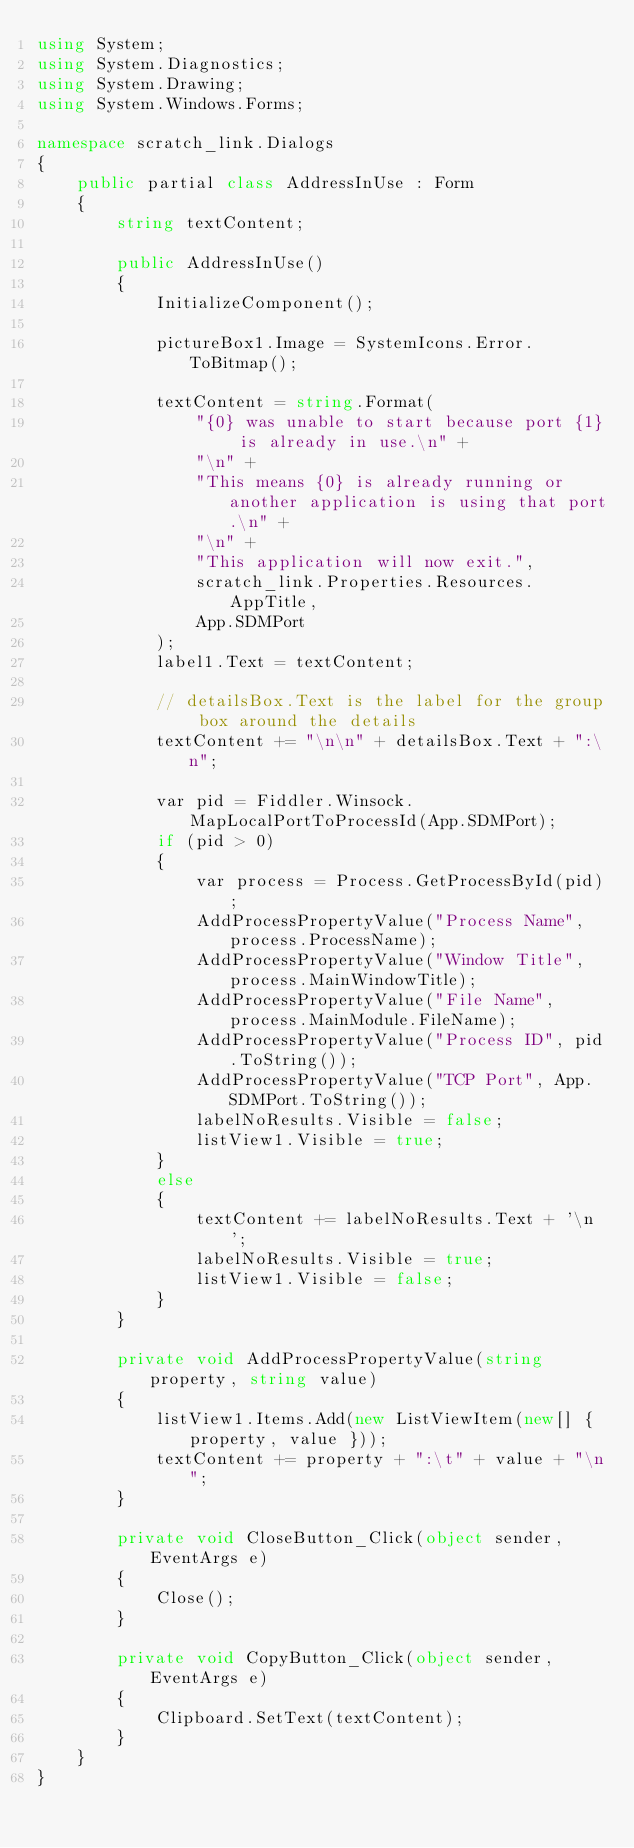Convert code to text. <code><loc_0><loc_0><loc_500><loc_500><_C#_>using System;
using System.Diagnostics;
using System.Drawing;
using System.Windows.Forms;

namespace scratch_link.Dialogs
{
    public partial class AddressInUse : Form
    {
        string textContent;

        public AddressInUse()
        {
            InitializeComponent();

            pictureBox1.Image = SystemIcons.Error.ToBitmap();

            textContent = string.Format(
                "{0} was unable to start because port {1} is already in use.\n" +
                "\n" +
                "This means {0} is already running or another application is using that port.\n" +
                "\n" +
                "This application will now exit.",
                scratch_link.Properties.Resources.AppTitle,
                App.SDMPort
            );
            label1.Text = textContent;

            // detailsBox.Text is the label for the group box around the details
            textContent += "\n\n" + detailsBox.Text + ":\n";

            var pid = Fiddler.Winsock.MapLocalPortToProcessId(App.SDMPort);
            if (pid > 0)
            {
                var process = Process.GetProcessById(pid);
                AddProcessPropertyValue("Process Name", process.ProcessName);
                AddProcessPropertyValue("Window Title", process.MainWindowTitle);
                AddProcessPropertyValue("File Name", process.MainModule.FileName);
                AddProcessPropertyValue("Process ID", pid.ToString());
                AddProcessPropertyValue("TCP Port", App.SDMPort.ToString());
                labelNoResults.Visible = false;
                listView1.Visible = true;
            }
            else
            {
                textContent += labelNoResults.Text + '\n';
                labelNoResults.Visible = true;
                listView1.Visible = false;
            }
        }

        private void AddProcessPropertyValue(string property, string value)
        {
            listView1.Items.Add(new ListViewItem(new[] { property, value }));
            textContent += property + ":\t" + value + "\n";
        }

        private void CloseButton_Click(object sender, EventArgs e)
        {
            Close();
        }

        private void CopyButton_Click(object sender, EventArgs e)
        {
            Clipboard.SetText(textContent);
        }
    }
}
</code> 